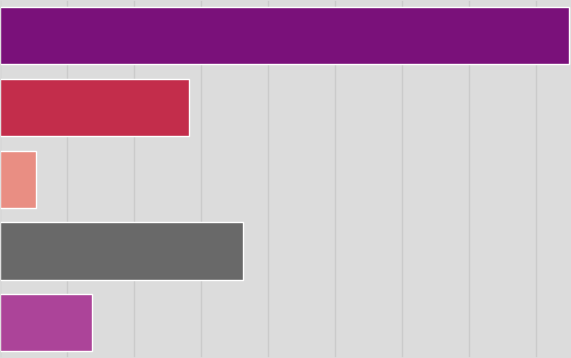<chart> <loc_0><loc_0><loc_500><loc_500><bar_chart><fcel>2012<fcel>2013<fcel>2014<fcel>2015<fcel>2016<nl><fcel>2.12468e+06<fcel>707684<fcel>135899<fcel>906562<fcel>344850<nl></chart> 